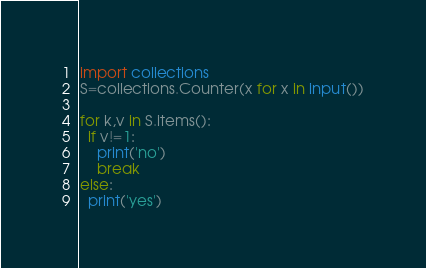<code> <loc_0><loc_0><loc_500><loc_500><_Python_>import collections
S=collections.Counter(x for x in input())

for k,v in S.items():
  if v!=1:
    print('no')
    break
else:
  print('yes')</code> 